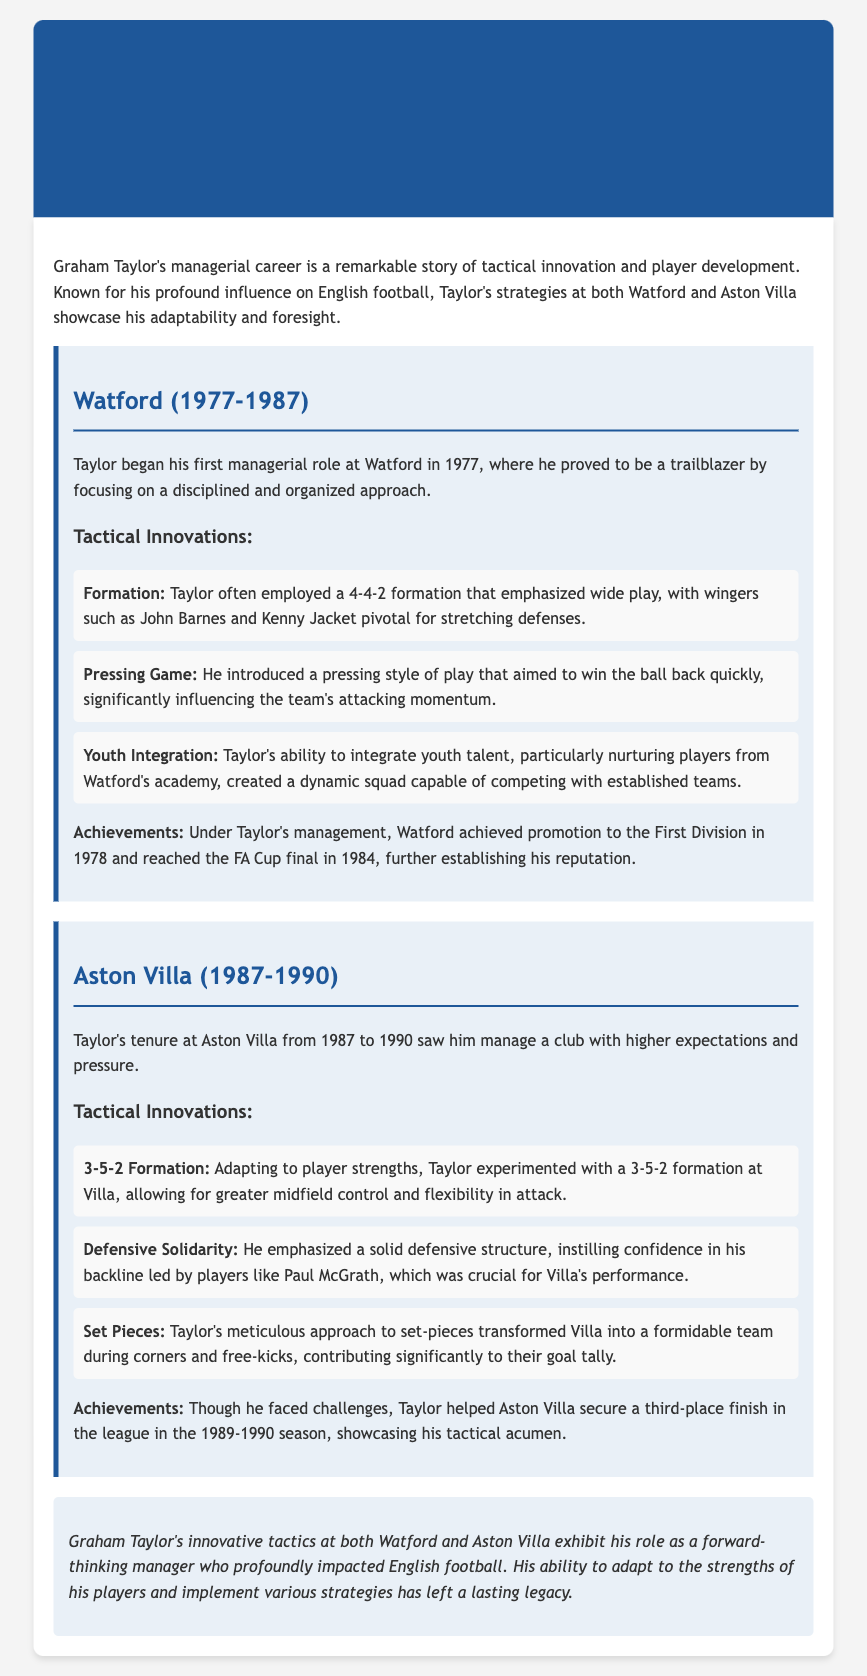What was Graham Taylor's first managerial role? The document states that Graham Taylor began his first managerial role at Watford in 1977.
Answer: Watford Which formation did Taylor often use at Watford? The document mentions that Taylor often employed a 4-4-2 formation at Watford.
Answer: 4-4-2 What tactical innovation did Taylor introduce at Watford? The document lists that he introduced a pressing style of play as a tactical innovation at Watford.
Answer: Pressing Game What was a significant achievement of Taylor's time at Aston Villa? According to the document, a significant achievement was securing a third-place finish in the league in the 1989-1990 season.
Answer: Third-place finish Which player was highlighted as part of the solid defensive structure at Aston Villa? The document specifies that Paul McGrath was part of the solid defensive structure emphasized by Taylor.
Answer: Paul McGrath What tactical formation did Taylor experiment with at Aston Villa? The document indicates that he experimented with a 3-5-2 formation at Aston Villa.
Answer: 3-5-2 How long did Graham Taylor manage Watford? The document states Taylor managed Watford from 1977 to 1987, which totals 10 years.
Answer: 10 years Which club achieved promotion to the First Division under Taylor's management? The document mentions that Watford achieved promotion to the First Division in 1978.
Answer: Watford 